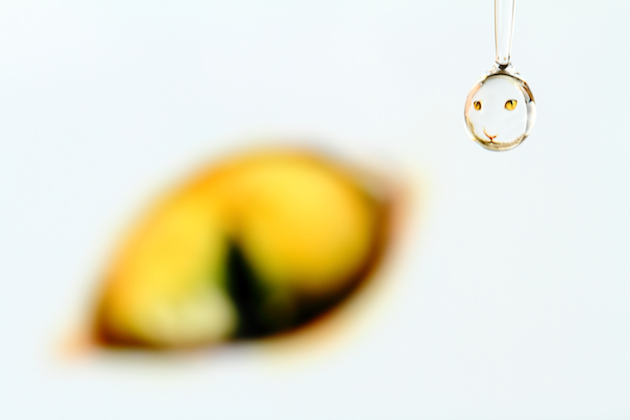How might one use this image in a creative project? The image can be used in various ways for creative projects. For instance, it might serve as an eye-catching addition to a collection of photographs showcasing the beauty and complexity of macro photography. Alternatively, the image can be utilized in advertising or promotional materials to evoke themes of clarity, purity, or happiness due to the smiley face. In a more artistic sense, it could be a metaphor in a visual story or campaign, representing finding joy in small, everyday moments. 